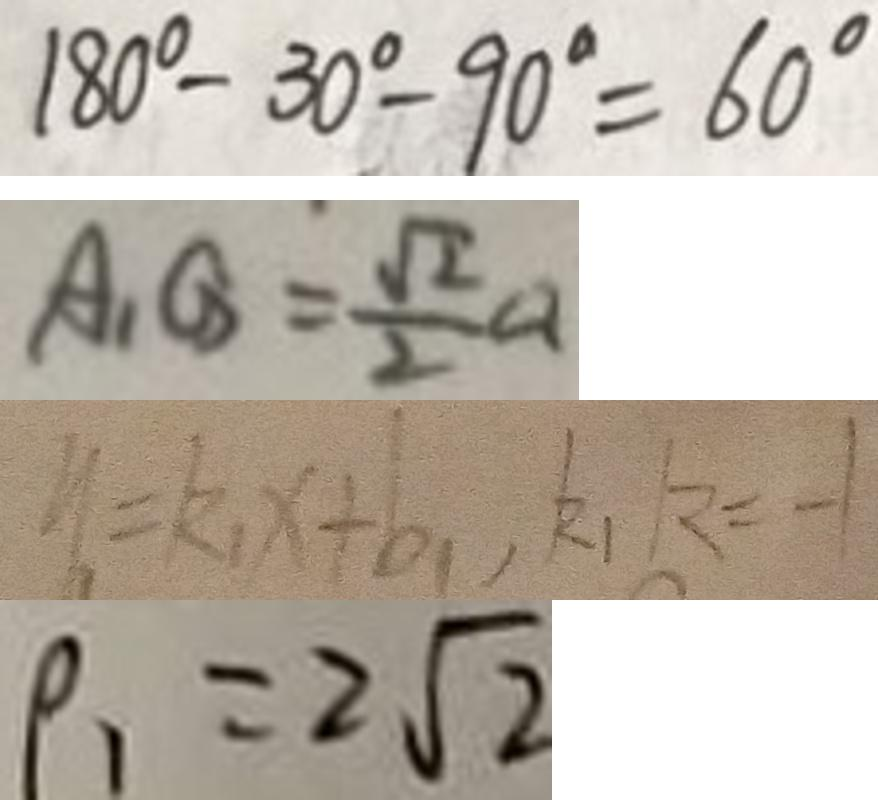Convert formula to latex. <formula><loc_0><loc_0><loc_500><loc_500>1 8 0 ^ { \circ } - 3 0 ^ { \circ } - 9 0 ^ { \circ } = 6 0 ^ { \circ } 
 A _ { 1 } G = \frac { \sqrt { 2 } } { 2 } a 
 y = k _ { 1 } x + b _ { 1 } , k _ { 1 } k = - 1 
 \rho _ { 1 } = 2 \sqrt { 2 }</formula> 